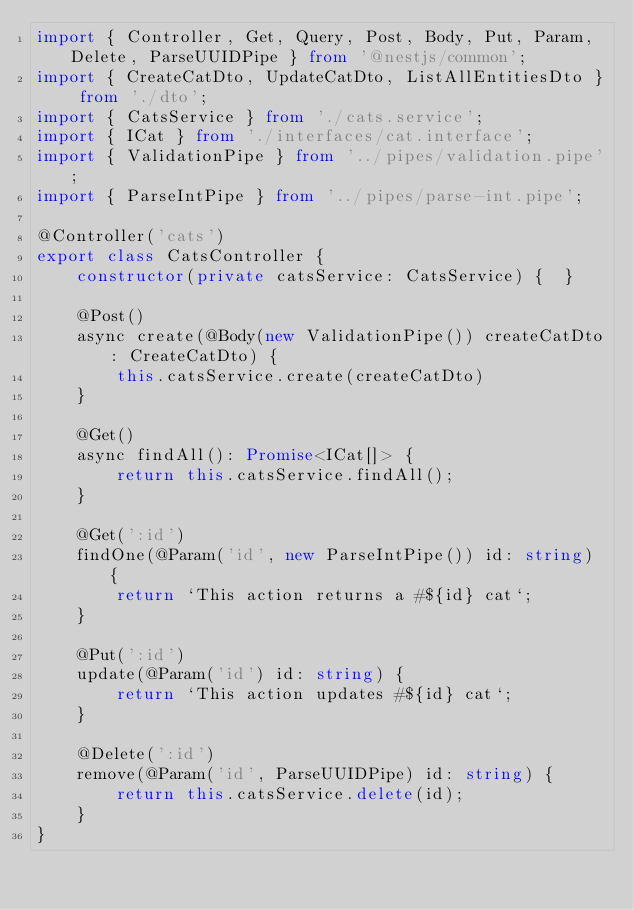<code> <loc_0><loc_0><loc_500><loc_500><_TypeScript_>import { Controller, Get, Query, Post, Body, Put, Param, Delete, ParseUUIDPipe } from '@nestjs/common';
import { CreateCatDto, UpdateCatDto, ListAllEntitiesDto } from './dto';
import { CatsService } from './cats.service';
import { ICat } from './interfaces/cat.interface';
import { ValidationPipe } from '../pipes/validation.pipe';
import { ParseIntPipe } from '../pipes/parse-int.pipe';

@Controller('cats')
export class CatsController {
    constructor(private catsService: CatsService) {  }

    @Post() 
    async create(@Body(new ValidationPipe()) createCatDto: CreateCatDto) {
        this.catsService.create(createCatDto)
    }

    @Get()
    async findAll(): Promise<ICat[]> {
        return this.catsService.findAll();
    }

    @Get(':id')
    findOne(@Param('id', new ParseIntPipe()) id: string) {
        return `This action returns a #${id} cat`;
    }

    @Put(':id')
    update(@Param('id') id: string) {
        return `This action updates #${id} cat`;
    }

    @Delete(':id')
    remove(@Param('id', ParseUUIDPipe) id: string) {
        return this.catsService.delete(id);
    }
}
</code> 